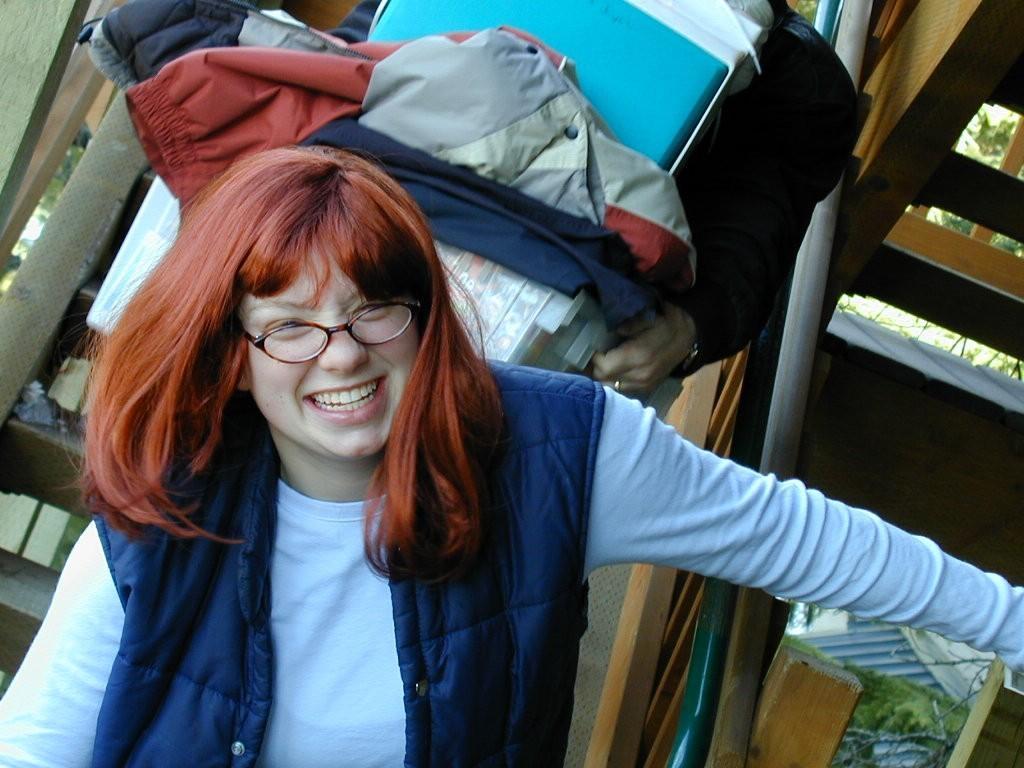Describe this image in one or two sentences. In this image, we can see a person wearing spectacles. We can see the railing and some stairs. We can see a person's hand holding some objects. We can also see some plants and trees. 